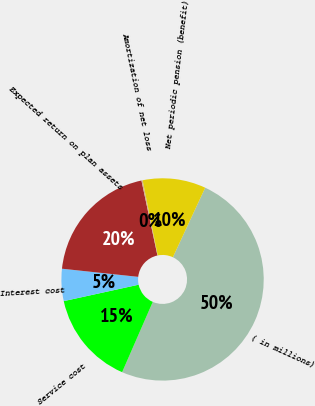Convert chart to OTSL. <chart><loc_0><loc_0><loc_500><loc_500><pie_chart><fcel>( in millions)<fcel>Service cost<fcel>Interest cost<fcel>Expected return on plan assets<fcel>Amortization of net loss<fcel>Net periodic pension (benefit)<nl><fcel>49.62%<fcel>15.02%<fcel>5.13%<fcel>19.96%<fcel>0.19%<fcel>10.08%<nl></chart> 